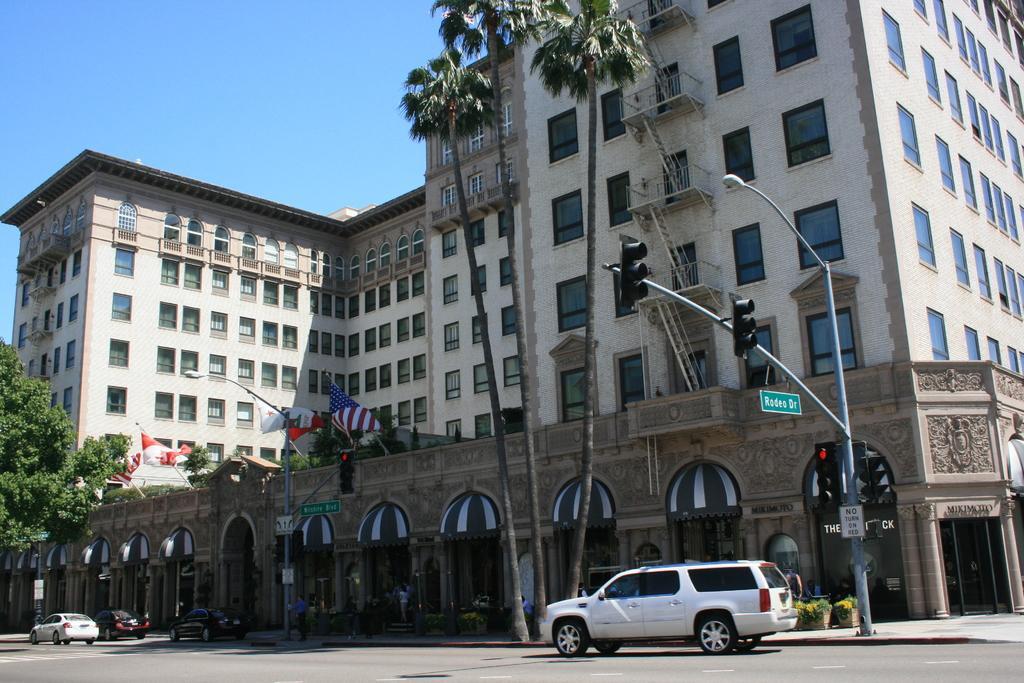Could you give a brief overview of what you see in this image? Here we can see four vehicles on the road. In the background there are few persons standing and few are sitting on the chair on the foot path and we can also see buildings,light poles,traffic signal poles,trees,windows,house plants,doors and sky. 